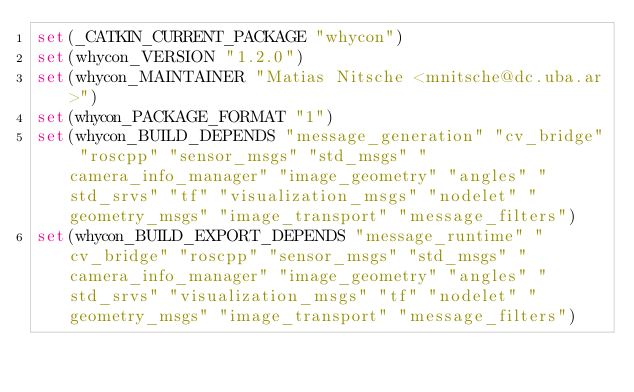Convert code to text. <code><loc_0><loc_0><loc_500><loc_500><_CMake_>set(_CATKIN_CURRENT_PACKAGE "whycon")
set(whycon_VERSION "1.2.0")
set(whycon_MAINTAINER "Matias Nitsche <mnitsche@dc.uba.ar>")
set(whycon_PACKAGE_FORMAT "1")
set(whycon_BUILD_DEPENDS "message_generation" "cv_bridge" "roscpp" "sensor_msgs" "std_msgs" "camera_info_manager" "image_geometry" "angles" "std_srvs" "tf" "visualization_msgs" "nodelet" "geometry_msgs" "image_transport" "message_filters")
set(whycon_BUILD_EXPORT_DEPENDS "message_runtime" "cv_bridge" "roscpp" "sensor_msgs" "std_msgs" "camera_info_manager" "image_geometry" "angles" "std_srvs" "visualization_msgs" "tf" "nodelet" "geometry_msgs" "image_transport" "message_filters")</code> 